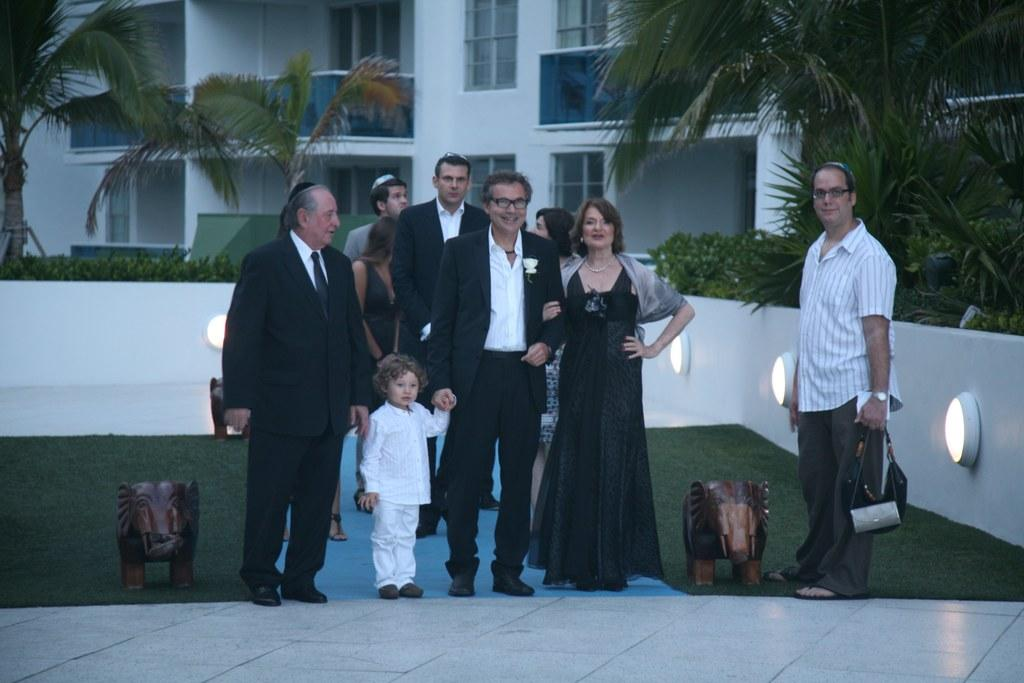What can be seen on the floor in the image? There are persons in different color dresses standing on the floor. What is visible in the background of the image? There are plants, trees, and a building with glass windows in the background. What part of the building is visible in the image? The provided facts do not specify a particular part of the building that is visible in the image. --- Facts: 1. There is a person holding a book in the image. 2. The person is sitting on a chair. 3. There is a table next to the chair. 4. There is a lamp on the table. 5. The background of the image is dark. Absurd Topics: dance, ocean, bird Conversation: What is the person in the image holding? The person in the image is holding a book. What is the person's position in the image? The person is sitting on a chair. What is located next to the chair? There is a table next to the chair. What is on the table? There is a lamp on the table. Reasoning: Let's think step by step in order to produce the conversation. We start by identifying the main subject in the image, which is the person holding a book. Then, we expand the conversation to include the person's position (sitting on a chair) and the objects around them (table and lamp). Each question is designed to elicit a specific detail about the image that is known from the provided facts. Absurd Question/Answer: Can you see any ocean waves in the image? There is no reference to an ocean or waves in the image; the background is described as dark. 